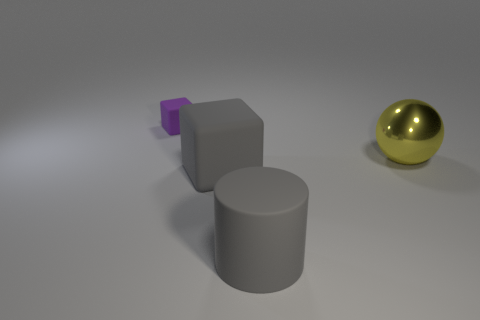Is the color of the big cylinder the same as the large matte block?
Offer a very short reply. Yes. What is the size of the matte thing that is the same color as the cylinder?
Ensure brevity in your answer.  Large. Does the gray thing behind the rubber cylinder have the same shape as the thing that is behind the big yellow shiny sphere?
Offer a terse response. Yes. What is the material of the thing that is the same color as the large rubber cylinder?
Offer a terse response. Rubber. Are there any blocks that have the same color as the large rubber cylinder?
Offer a terse response. Yes. There is a block that is in front of the object behind the large sphere; what is its color?
Ensure brevity in your answer.  Gray. There is a cube that is in front of the big yellow metal ball; how big is it?
Provide a succinct answer. Large. Is there a small gray sphere that has the same material as the gray cylinder?
Your answer should be very brief. No. What number of small matte objects have the same shape as the large yellow metallic thing?
Make the answer very short. 0. What shape is the big matte object in front of the rubber cube in front of the small purple rubber object behind the gray block?
Offer a terse response. Cylinder. 